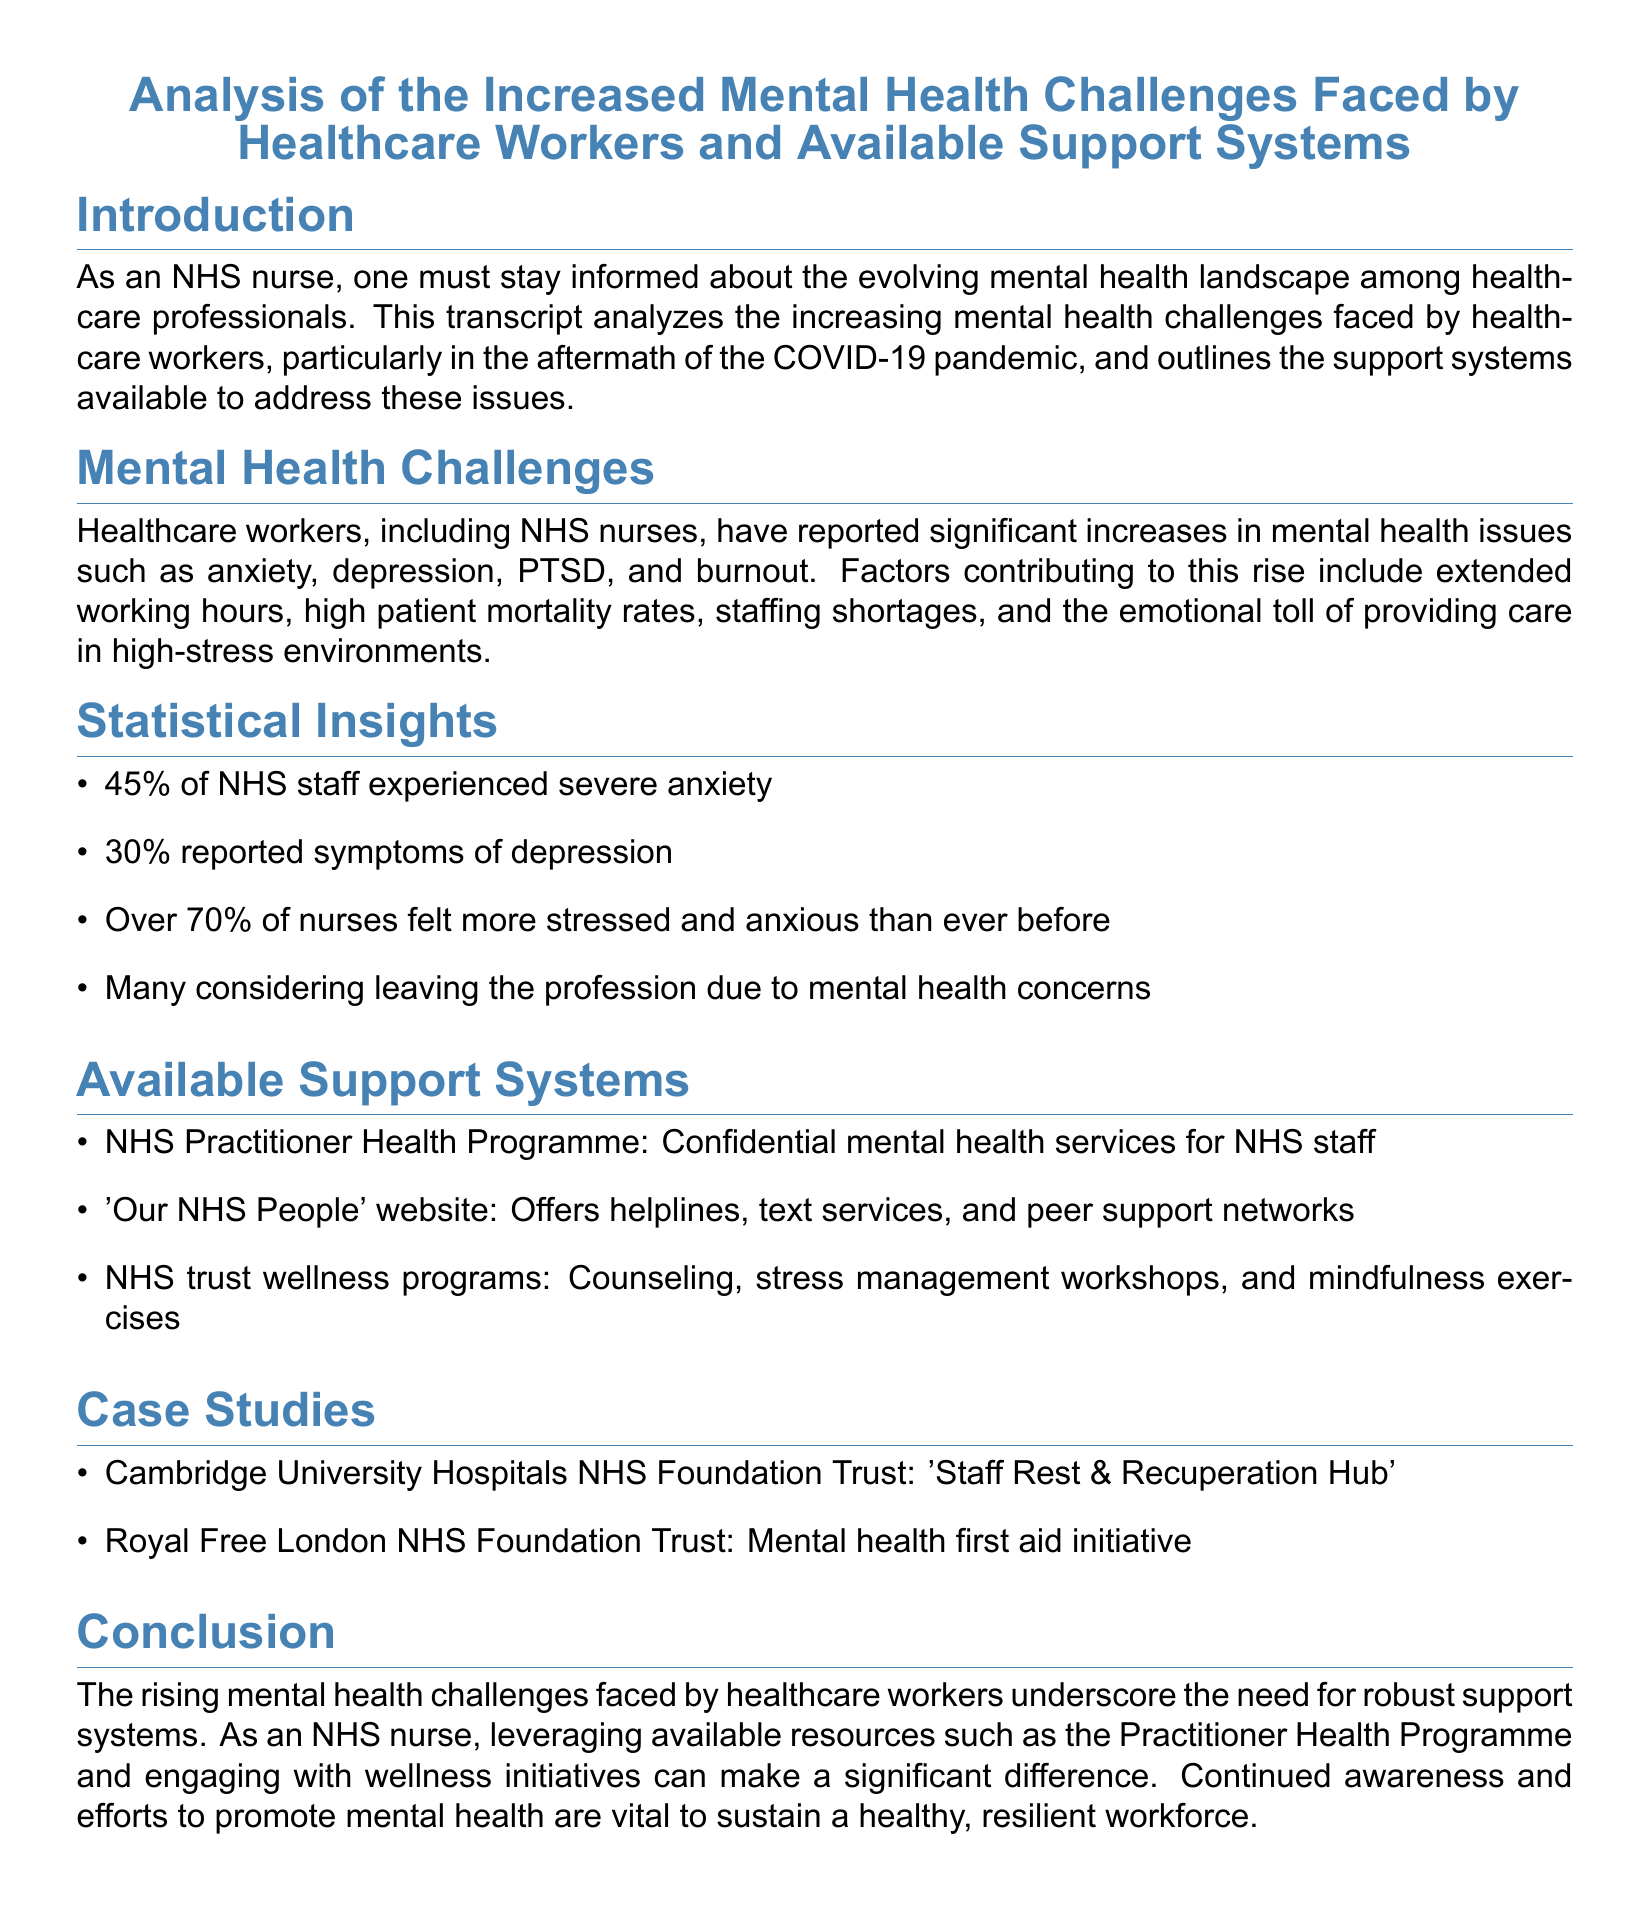What percentage of NHS staff experienced severe anxiety? The document states that 45% of NHS staff experienced severe anxiety.
Answer: 45% What is one factor contributing to increased mental health issues among healthcare workers? The document lists extended working hours, high patient mortality rates, staffing shortages, and emotional tolls as factors, but only one is needed.
Answer: Extended working hours What initiative was launched by Cambridge University Hospitals NHS Foundation Trust? The document mentions the 'Staff Rest & Recuperation Hub' as an initiative launched by this trust.
Answer: Staff Rest & Recuperation Hub What percentage of nurses felt more stressed and anxious than ever before? According to the document, over 70% of nurses felt more stressed and anxious than ever before.
Answer: Over 70% What support system offers confidential mental health services for NHS staff? The NHS Practitioner Health Programme provides confidential mental health services for NHS staff.
Answer: NHS Practitioner Health Programme What mental health issue did 30% of healthcare workers report? The document indicates that 30% of healthcare workers reported symptoms of depression.
Answer: Symptoms of depression Which website offers helplines and peer support networks? 'Our NHS People' website offers helplines, text services, and peer support networks.
Answer: Our NHS People What is a key reason many healthcare workers are considering leaving their profession? The document highlights mental health concerns as a key reason for many workers considering leaving the profession.
Answer: Mental health concerns What type of wellness program might NHS trusts offer? The document cites counseling, stress management workshops, and mindfulness exercises as examples of wellness programs.
Answer: Counseling, stress management workshops, mindfulness exercises 